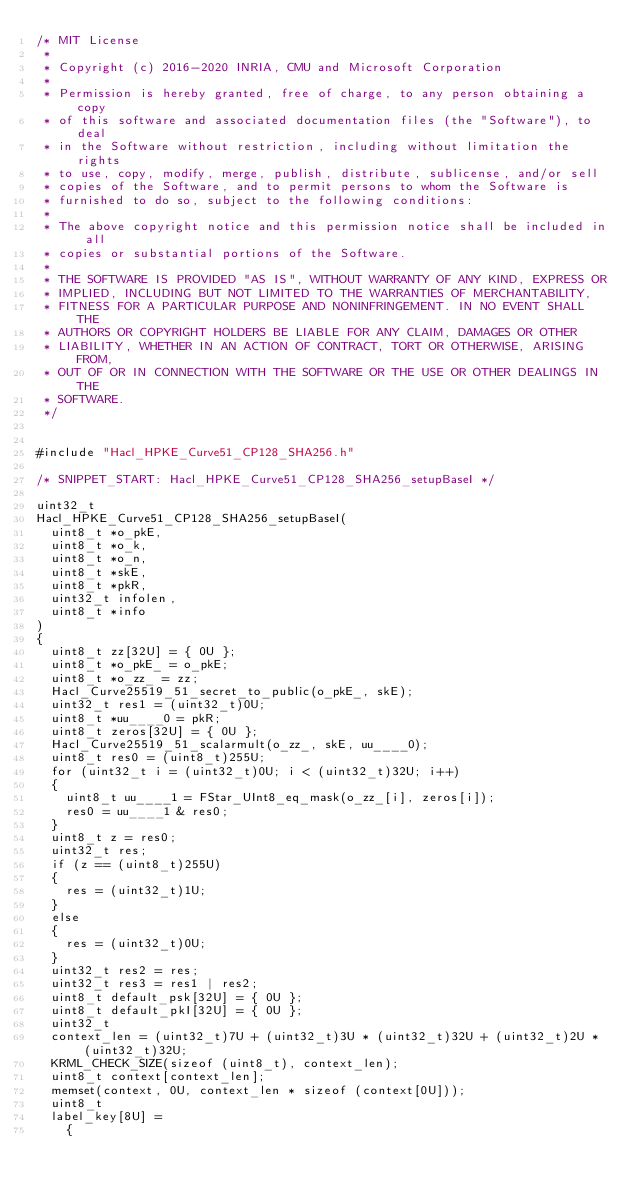Convert code to text. <code><loc_0><loc_0><loc_500><loc_500><_C_>/* MIT License
 *
 * Copyright (c) 2016-2020 INRIA, CMU and Microsoft Corporation
 *
 * Permission is hereby granted, free of charge, to any person obtaining a copy
 * of this software and associated documentation files (the "Software"), to deal
 * in the Software without restriction, including without limitation the rights
 * to use, copy, modify, merge, publish, distribute, sublicense, and/or sell
 * copies of the Software, and to permit persons to whom the Software is
 * furnished to do so, subject to the following conditions:
 *
 * The above copyright notice and this permission notice shall be included in all
 * copies or substantial portions of the Software.
 *
 * THE SOFTWARE IS PROVIDED "AS IS", WITHOUT WARRANTY OF ANY KIND, EXPRESS OR
 * IMPLIED, INCLUDING BUT NOT LIMITED TO THE WARRANTIES OF MERCHANTABILITY,
 * FITNESS FOR A PARTICULAR PURPOSE AND NONINFRINGEMENT. IN NO EVENT SHALL THE
 * AUTHORS OR COPYRIGHT HOLDERS BE LIABLE FOR ANY CLAIM, DAMAGES OR OTHER
 * LIABILITY, WHETHER IN AN ACTION OF CONTRACT, TORT OR OTHERWISE, ARISING FROM,
 * OUT OF OR IN CONNECTION WITH THE SOFTWARE OR THE USE OR OTHER DEALINGS IN THE
 * SOFTWARE.
 */


#include "Hacl_HPKE_Curve51_CP128_SHA256.h"

/* SNIPPET_START: Hacl_HPKE_Curve51_CP128_SHA256_setupBaseI */

uint32_t
Hacl_HPKE_Curve51_CP128_SHA256_setupBaseI(
  uint8_t *o_pkE,
  uint8_t *o_k,
  uint8_t *o_n,
  uint8_t *skE,
  uint8_t *pkR,
  uint32_t infolen,
  uint8_t *info
)
{
  uint8_t zz[32U] = { 0U };
  uint8_t *o_pkE_ = o_pkE;
  uint8_t *o_zz_ = zz;
  Hacl_Curve25519_51_secret_to_public(o_pkE_, skE);
  uint32_t res1 = (uint32_t)0U;
  uint8_t *uu____0 = pkR;
  uint8_t zeros[32U] = { 0U };
  Hacl_Curve25519_51_scalarmult(o_zz_, skE, uu____0);
  uint8_t res0 = (uint8_t)255U;
  for (uint32_t i = (uint32_t)0U; i < (uint32_t)32U; i++)
  {
    uint8_t uu____1 = FStar_UInt8_eq_mask(o_zz_[i], zeros[i]);
    res0 = uu____1 & res0;
  }
  uint8_t z = res0;
  uint32_t res;
  if (z == (uint8_t)255U)
  {
    res = (uint32_t)1U;
  }
  else
  {
    res = (uint32_t)0U;
  }
  uint32_t res2 = res;
  uint32_t res3 = res1 | res2;
  uint8_t default_psk[32U] = { 0U };
  uint8_t default_pkI[32U] = { 0U };
  uint32_t
  context_len = (uint32_t)7U + (uint32_t)3U * (uint32_t)32U + (uint32_t)2U * (uint32_t)32U;
  KRML_CHECK_SIZE(sizeof (uint8_t), context_len);
  uint8_t context[context_len];
  memset(context, 0U, context_len * sizeof (context[0U]));
  uint8_t
  label_key[8U] =
    {</code> 